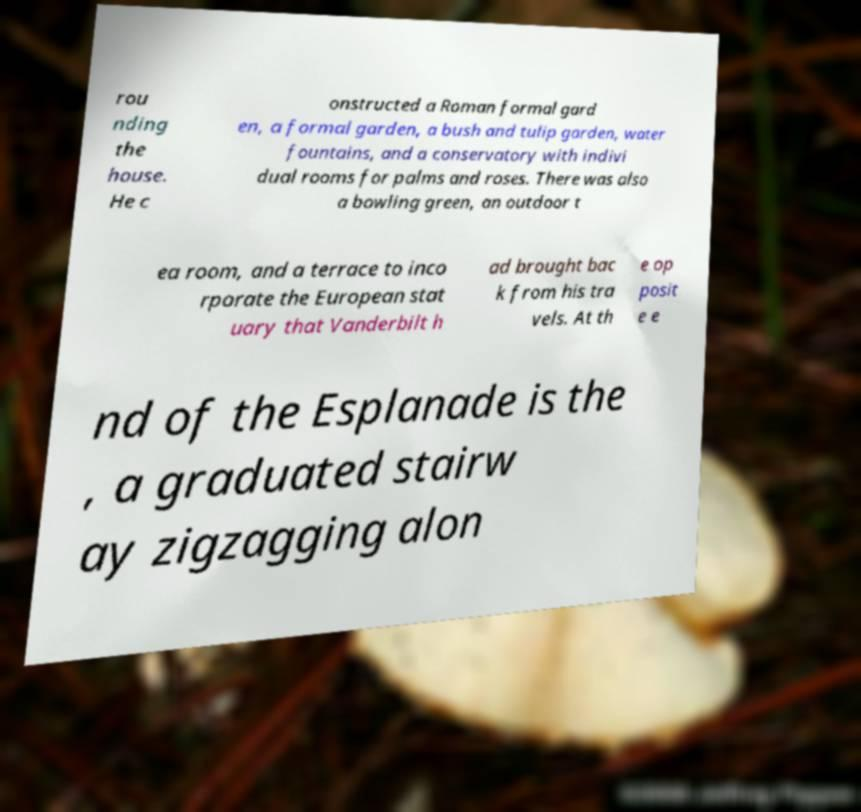Can you read and provide the text displayed in the image?This photo seems to have some interesting text. Can you extract and type it out for me? rou nding the house. He c onstructed a Roman formal gard en, a formal garden, a bush and tulip garden, water fountains, and a conservatory with indivi dual rooms for palms and roses. There was also a bowling green, an outdoor t ea room, and a terrace to inco rporate the European stat uary that Vanderbilt h ad brought bac k from his tra vels. At th e op posit e e nd of the Esplanade is the , a graduated stairw ay zigzagging alon 